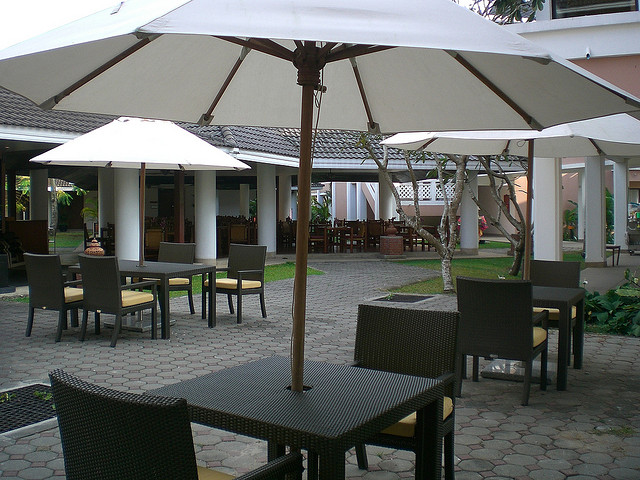<image>What location is this? It is ambiguous to determine the exact location. However, it is more likely to be outside or a outdoor restaurant. What location is this? I am not sure what location this is. It can be either outdoor or a restaurant. 